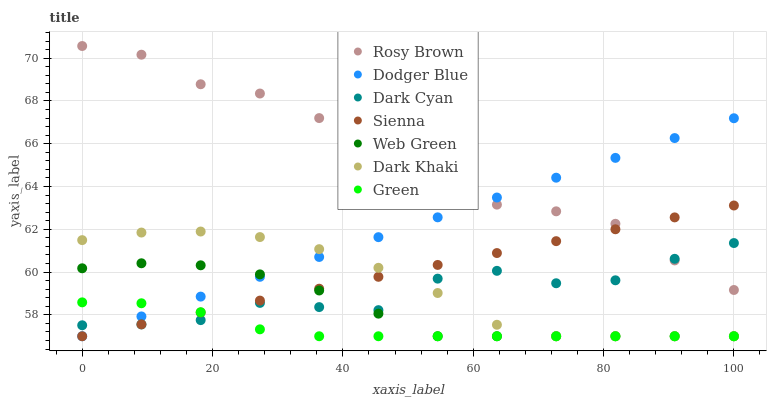Does Green have the minimum area under the curve?
Answer yes or no. Yes. Does Rosy Brown have the maximum area under the curve?
Answer yes or no. Yes. Does Web Green have the minimum area under the curve?
Answer yes or no. No. Does Web Green have the maximum area under the curve?
Answer yes or no. No. Is Sienna the smoothest?
Answer yes or no. Yes. Is Rosy Brown the roughest?
Answer yes or no. Yes. Is Web Green the smoothest?
Answer yes or no. No. Is Web Green the roughest?
Answer yes or no. No. Does Dark Khaki have the lowest value?
Answer yes or no. Yes. Does Rosy Brown have the lowest value?
Answer yes or no. No. Does Rosy Brown have the highest value?
Answer yes or no. Yes. Does Web Green have the highest value?
Answer yes or no. No. Is Web Green less than Rosy Brown?
Answer yes or no. Yes. Is Rosy Brown greater than Dark Khaki?
Answer yes or no. Yes. Does Web Green intersect Dark Khaki?
Answer yes or no. Yes. Is Web Green less than Dark Khaki?
Answer yes or no. No. Is Web Green greater than Dark Khaki?
Answer yes or no. No. Does Web Green intersect Rosy Brown?
Answer yes or no. No. 